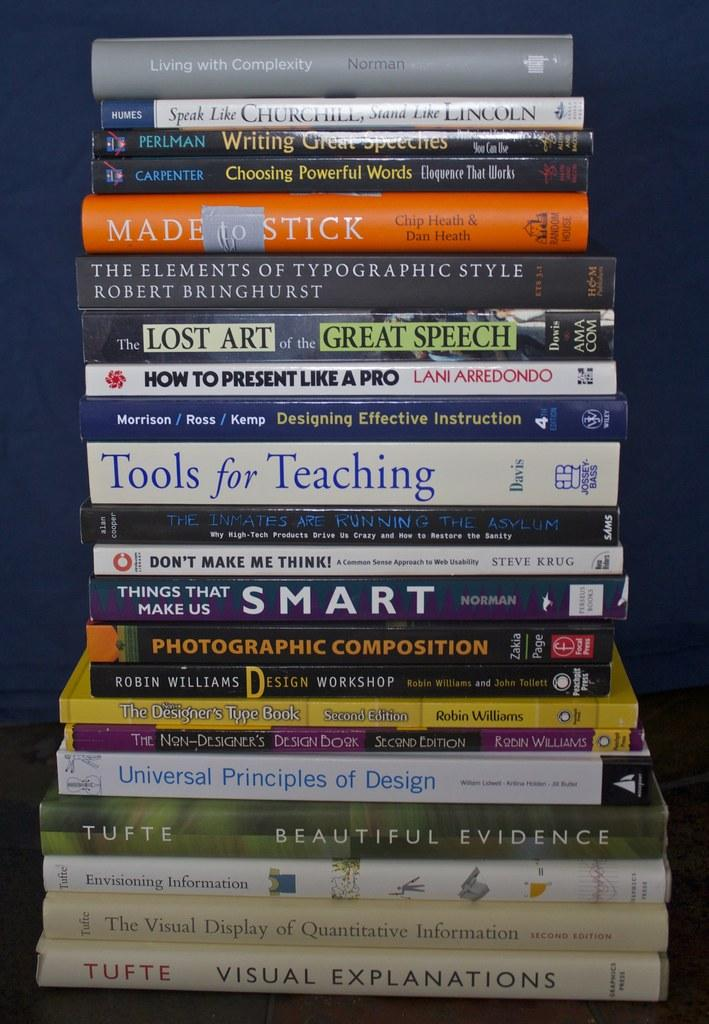<image>
Share a concise interpretation of the image provided. A large stack of books with the top one being titled Living with Complexity. 